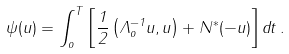<formula> <loc_0><loc_0><loc_500><loc_500>\psi ( u ) = \int _ { o } ^ { T } \left [ \frac { 1 } { 2 } \left ( \Lambda _ { o } ^ { - 1 } u , u \right ) + N ^ { \ast } ( - u ) \right ] d t \, .</formula> 